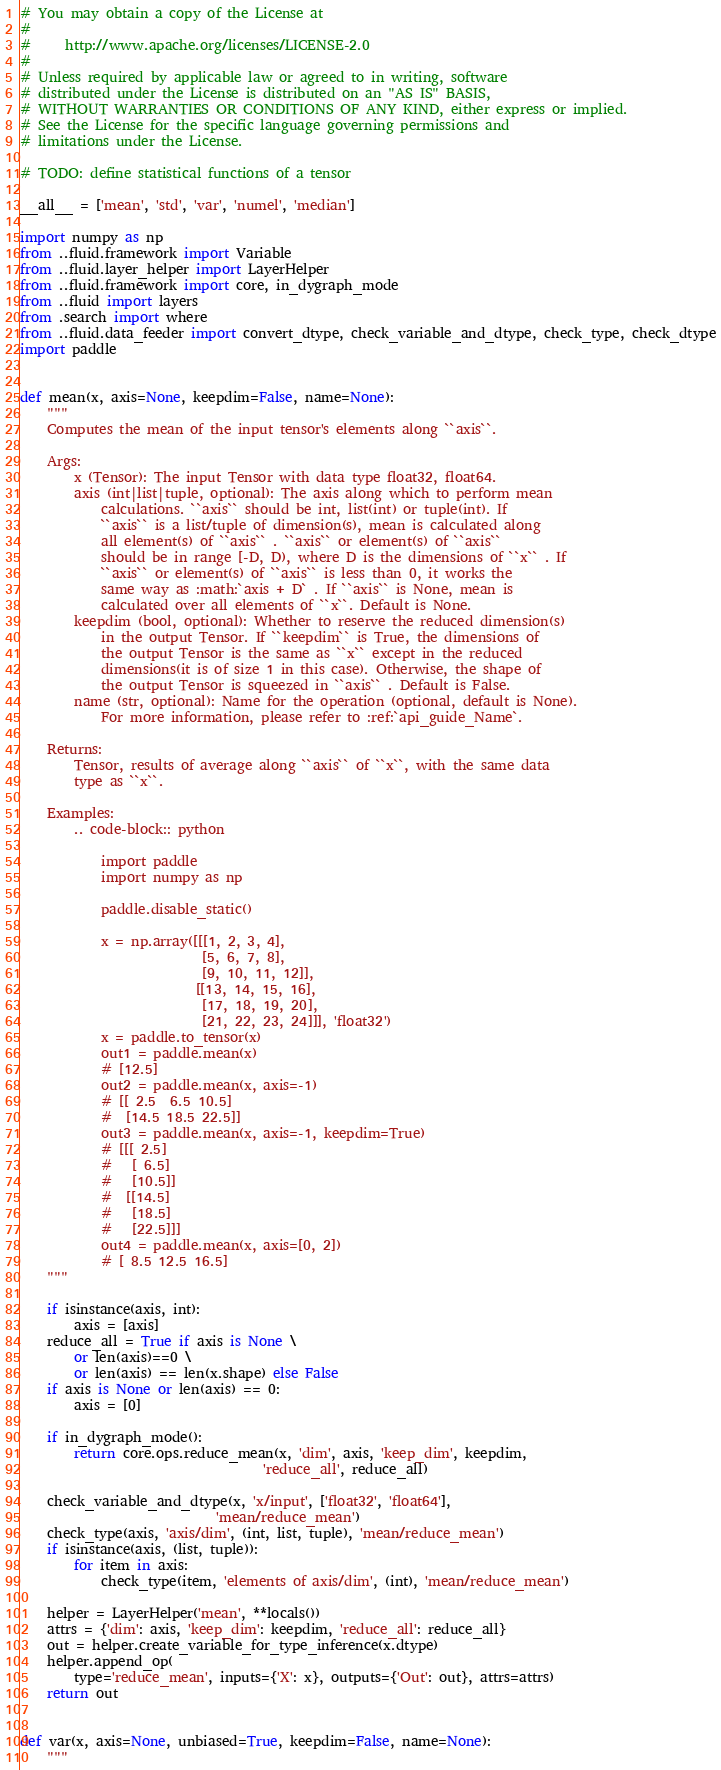<code> <loc_0><loc_0><loc_500><loc_500><_Python_># You may obtain a copy of the License at
#
#     http://www.apache.org/licenses/LICENSE-2.0
#
# Unless required by applicable law or agreed to in writing, software
# distributed under the License is distributed on an "AS IS" BASIS,
# WITHOUT WARRANTIES OR CONDITIONS OF ANY KIND, either express or implied.
# See the License for the specific language governing permissions and
# limitations under the License.

# TODO: define statistical functions of a tensor  

__all__ = ['mean', 'std', 'var', 'numel', 'median']

import numpy as np
from ..fluid.framework import Variable
from ..fluid.layer_helper import LayerHelper
from ..fluid.framework import core, in_dygraph_mode
from ..fluid import layers
from .search import where
from ..fluid.data_feeder import convert_dtype, check_variable_and_dtype, check_type, check_dtype
import paddle


def mean(x, axis=None, keepdim=False, name=None):
    """
    Computes the mean of the input tensor's elements along ``axis``.

    Args:
        x (Tensor): The input Tensor with data type float32, float64.
        axis (int|list|tuple, optional): The axis along which to perform mean
            calculations. ``axis`` should be int, list(int) or tuple(int). If
            ``axis`` is a list/tuple of dimension(s), mean is calculated along
            all element(s) of ``axis`` . ``axis`` or element(s) of ``axis``
            should be in range [-D, D), where D is the dimensions of ``x`` . If
            ``axis`` or element(s) of ``axis`` is less than 0, it works the
            same way as :math:`axis + D` . If ``axis`` is None, mean is
            calculated over all elements of ``x``. Default is None.
        keepdim (bool, optional): Whether to reserve the reduced dimension(s)
            in the output Tensor. If ``keepdim`` is True, the dimensions of
            the output Tensor is the same as ``x`` except in the reduced
            dimensions(it is of size 1 in this case). Otherwise, the shape of
            the output Tensor is squeezed in ``axis`` . Default is False.
        name (str, optional): Name for the operation (optional, default is None).
            For more information, please refer to :ref:`api_guide_Name`.

    Returns:
        Tensor, results of average along ``axis`` of ``x``, with the same data
        type as ``x``.

    Examples:
        .. code-block:: python

            import paddle
            import numpy as np

            paddle.disable_static()

            x = np.array([[[1, 2, 3, 4],
                           [5, 6, 7, 8],
                           [9, 10, 11, 12]],
                          [[13, 14, 15, 16],
                           [17, 18, 19, 20],
                           [21, 22, 23, 24]]], 'float32')
            x = paddle.to_tensor(x)
            out1 = paddle.mean(x)
            # [12.5]
            out2 = paddle.mean(x, axis=-1)
            # [[ 2.5  6.5 10.5]
            #  [14.5 18.5 22.5]]
            out3 = paddle.mean(x, axis=-1, keepdim=True)
            # [[[ 2.5]
            #   [ 6.5]
            #   [10.5]]
            #  [[14.5]
            #   [18.5]
            #   [22.5]]]
            out4 = paddle.mean(x, axis=[0, 2])
            # [ 8.5 12.5 16.5]
    """

    if isinstance(axis, int):
        axis = [axis]
    reduce_all = True if axis is None \
        or len(axis)==0 \
        or len(axis) == len(x.shape) else False
    if axis is None or len(axis) == 0:
        axis = [0]

    if in_dygraph_mode():
        return core.ops.reduce_mean(x, 'dim', axis, 'keep_dim', keepdim,
                                    'reduce_all', reduce_all)

    check_variable_and_dtype(x, 'x/input', ['float32', 'float64'],
                             'mean/reduce_mean')
    check_type(axis, 'axis/dim', (int, list, tuple), 'mean/reduce_mean')
    if isinstance(axis, (list, tuple)):
        for item in axis:
            check_type(item, 'elements of axis/dim', (int), 'mean/reduce_mean')

    helper = LayerHelper('mean', **locals())
    attrs = {'dim': axis, 'keep_dim': keepdim, 'reduce_all': reduce_all}
    out = helper.create_variable_for_type_inference(x.dtype)
    helper.append_op(
        type='reduce_mean', inputs={'X': x}, outputs={'Out': out}, attrs=attrs)
    return out


def var(x, axis=None, unbiased=True, keepdim=False, name=None):
    """</code> 